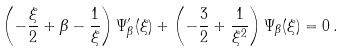<formula> <loc_0><loc_0><loc_500><loc_500>\left ( - \frac { \xi } { 2 } + \beta - \frac { 1 } { \xi } \right ) \Psi _ { \beta } ^ { \prime } ( \xi ) + \left ( - \frac { 3 } { 2 } + \frac { 1 } { \xi ^ { 2 } } \right ) \Psi _ { \beta } ( \xi ) = 0 \, .</formula> 